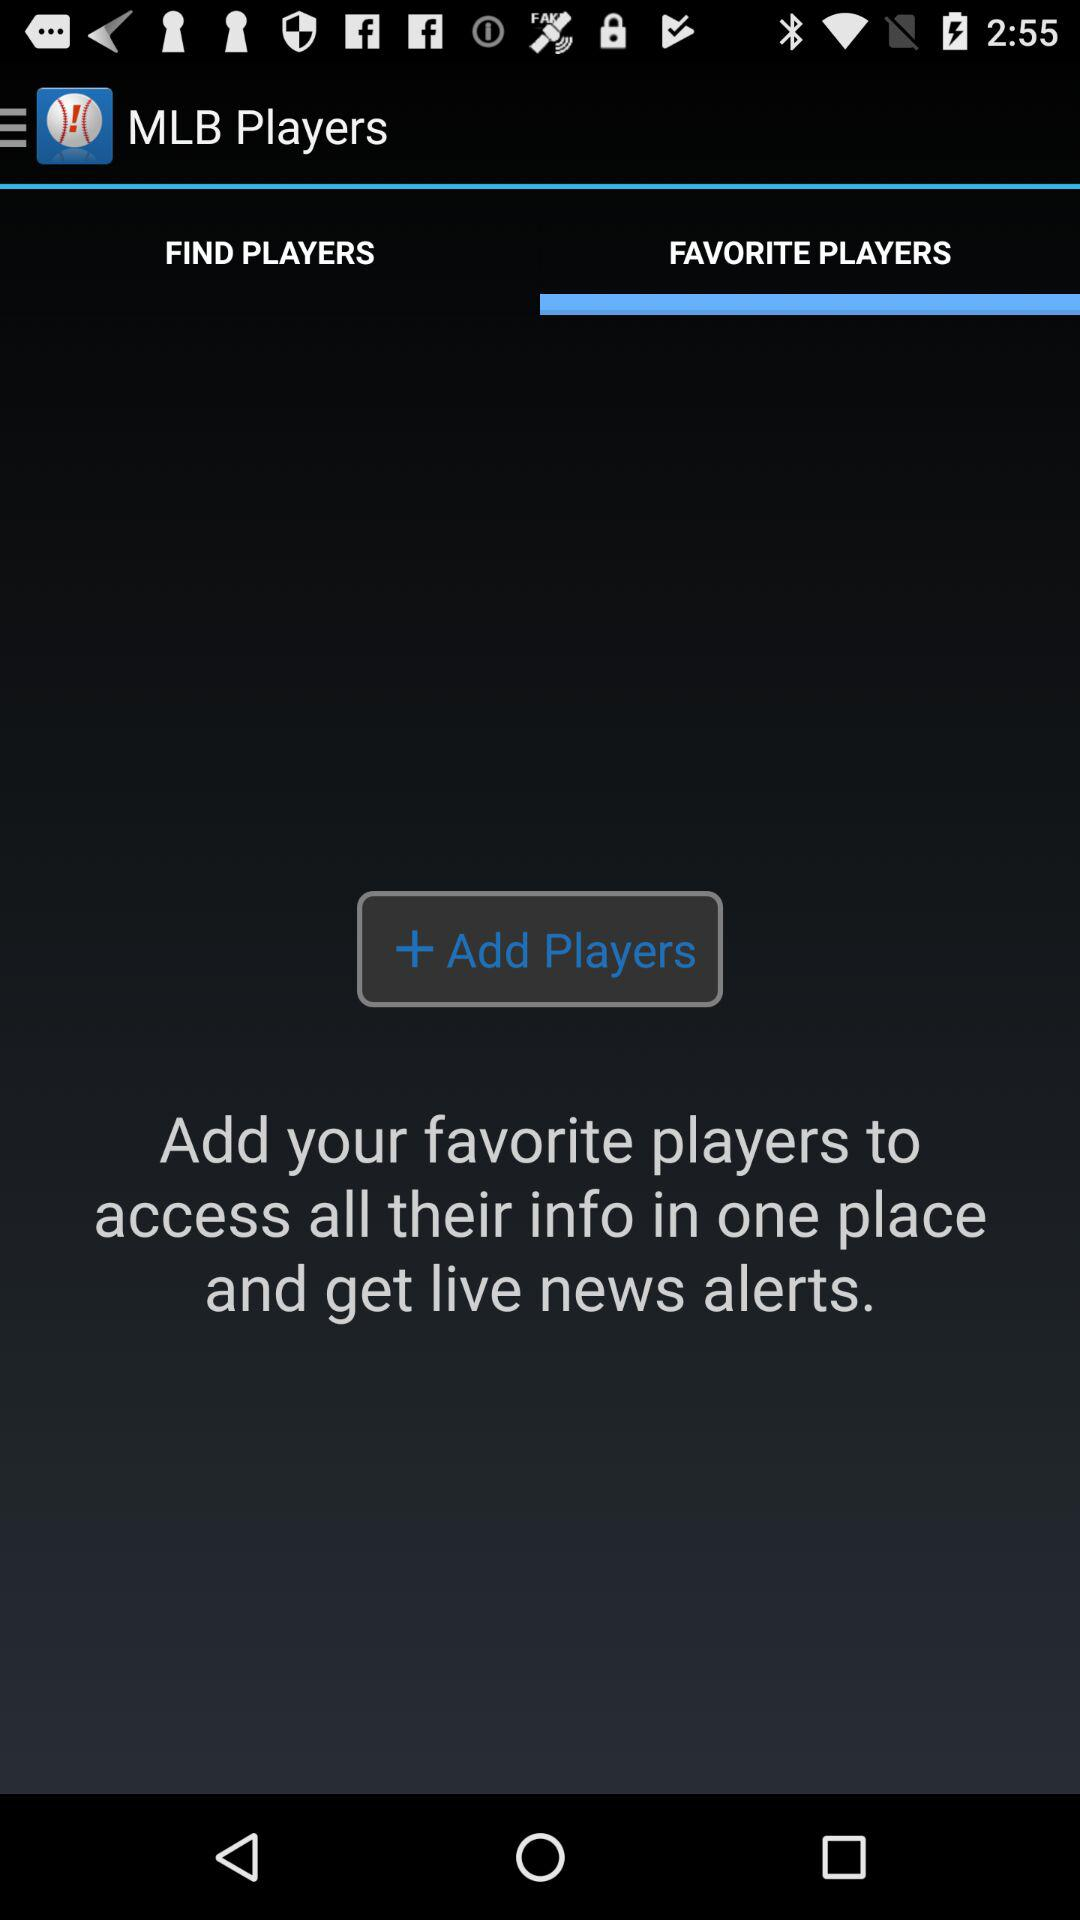How do you find players?
When the provided information is insufficient, respond with <no answer>. <no answer> 